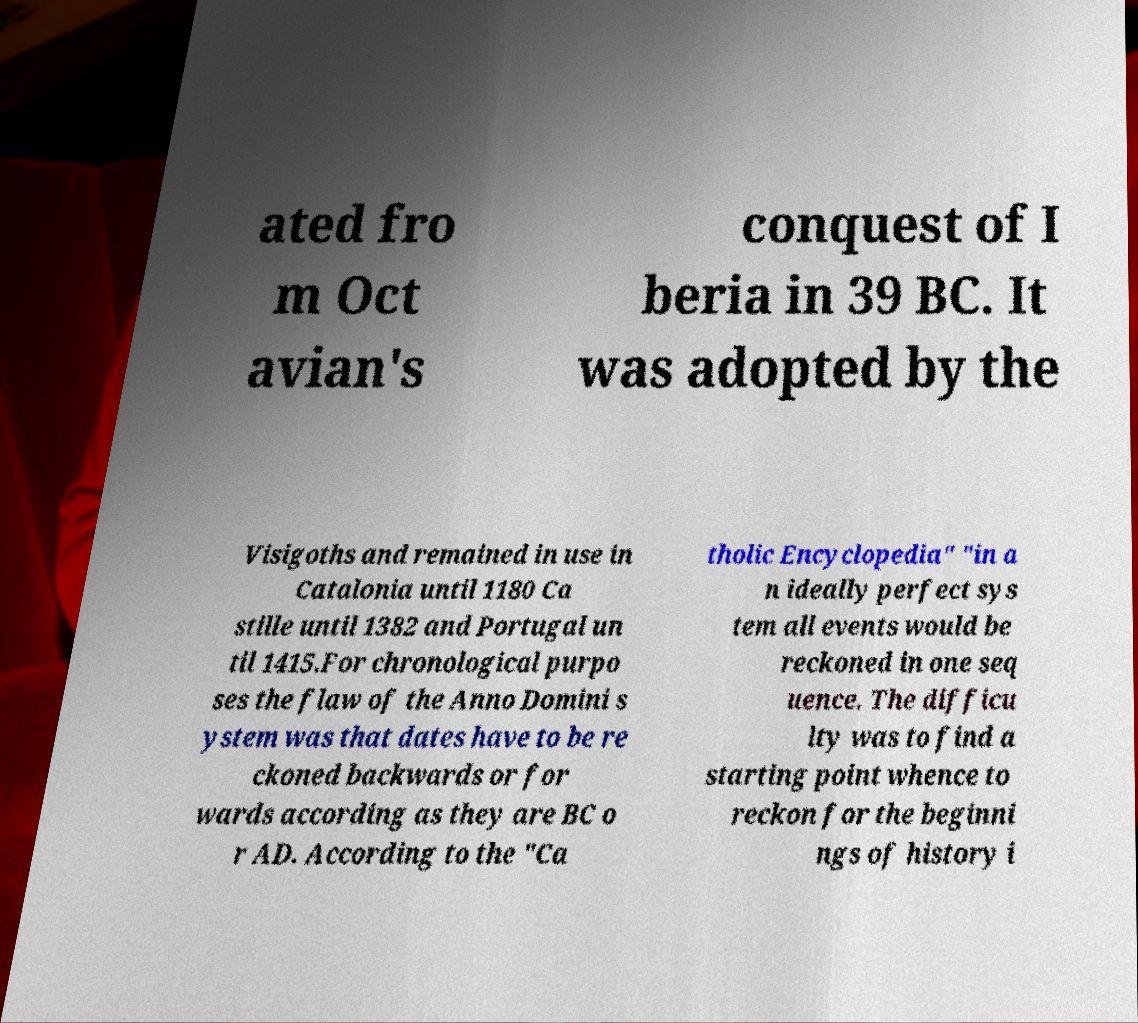There's text embedded in this image that I need extracted. Can you transcribe it verbatim? ated fro m Oct avian's conquest of I beria in 39 BC. It was adopted by the Visigoths and remained in use in Catalonia until 1180 Ca stille until 1382 and Portugal un til 1415.For chronological purpo ses the flaw of the Anno Domini s ystem was that dates have to be re ckoned backwards or for wards according as they are BC o r AD. According to the "Ca tholic Encyclopedia" "in a n ideally perfect sys tem all events would be reckoned in one seq uence. The difficu lty was to find a starting point whence to reckon for the beginni ngs of history i 